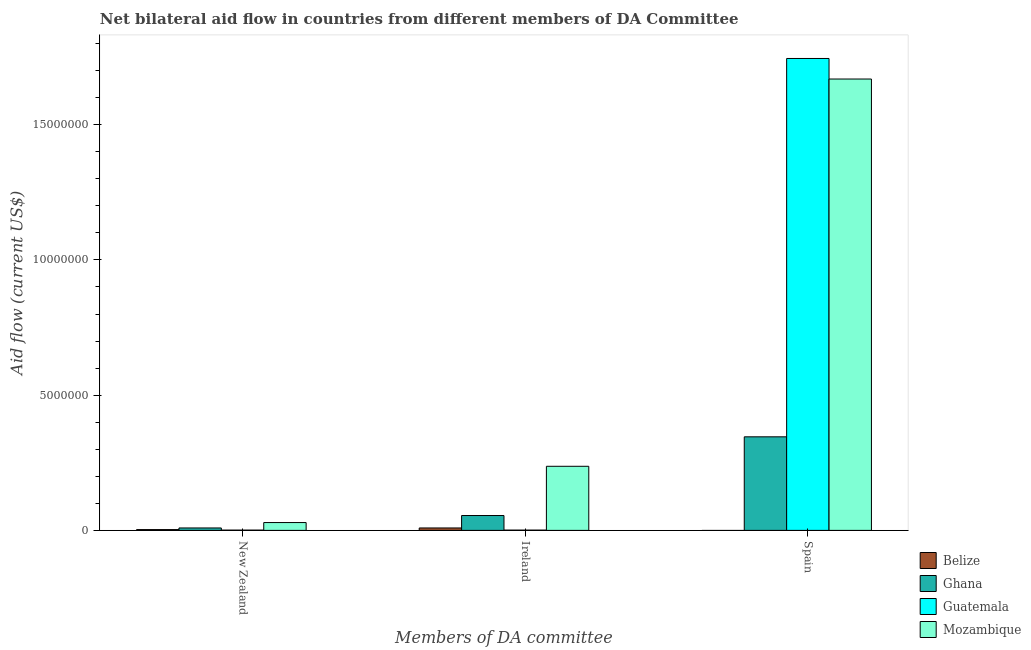How many groups of bars are there?
Make the answer very short. 3. Are the number of bars per tick equal to the number of legend labels?
Keep it short and to the point. No. How many bars are there on the 2nd tick from the left?
Provide a short and direct response. 4. What is the label of the 3rd group of bars from the left?
Your response must be concise. Spain. What is the amount of aid provided by new zealand in Ghana?
Your response must be concise. 9.00e+04. Across all countries, what is the maximum amount of aid provided by ireland?
Keep it short and to the point. 2.37e+06. Across all countries, what is the minimum amount of aid provided by spain?
Make the answer very short. 0. In which country was the amount of aid provided by ireland maximum?
Your response must be concise. Mozambique. What is the total amount of aid provided by new zealand in the graph?
Offer a very short reply. 4.20e+05. What is the difference between the amount of aid provided by new zealand in Guatemala and that in Mozambique?
Your response must be concise. -2.80e+05. What is the difference between the amount of aid provided by spain in Ghana and the amount of aid provided by ireland in Mozambique?
Give a very brief answer. 1.09e+06. What is the average amount of aid provided by spain per country?
Your answer should be very brief. 9.40e+06. What is the difference between the amount of aid provided by spain and amount of aid provided by new zealand in Mozambique?
Your answer should be compact. 1.64e+07. In how many countries, is the amount of aid provided by spain greater than 7000000 US$?
Ensure brevity in your answer.  2. What is the ratio of the amount of aid provided by new zealand in Guatemala to that in Mozambique?
Your response must be concise. 0.03. Is the difference between the amount of aid provided by ireland in Ghana and Mozambique greater than the difference between the amount of aid provided by spain in Ghana and Mozambique?
Keep it short and to the point. Yes. What is the difference between the highest and the second highest amount of aid provided by spain?
Offer a terse response. 7.60e+05. What is the difference between the highest and the lowest amount of aid provided by ireland?
Provide a succinct answer. 2.36e+06. Is it the case that in every country, the sum of the amount of aid provided by new zealand and amount of aid provided by ireland is greater than the amount of aid provided by spain?
Give a very brief answer. No. How many bars are there?
Your response must be concise. 11. Are all the bars in the graph horizontal?
Offer a terse response. No. How many countries are there in the graph?
Make the answer very short. 4. Does the graph contain grids?
Your answer should be compact. No. How many legend labels are there?
Make the answer very short. 4. How are the legend labels stacked?
Ensure brevity in your answer.  Vertical. What is the title of the graph?
Keep it short and to the point. Net bilateral aid flow in countries from different members of DA Committee. What is the label or title of the X-axis?
Make the answer very short. Members of DA committee. What is the label or title of the Y-axis?
Your response must be concise. Aid flow (current US$). What is the Aid flow (current US$) of Belize in New Zealand?
Offer a very short reply. 3.00e+04. What is the Aid flow (current US$) in Belize in Ireland?
Your response must be concise. 9.00e+04. What is the Aid flow (current US$) of Ghana in Ireland?
Your answer should be very brief. 5.50e+05. What is the Aid flow (current US$) in Mozambique in Ireland?
Your answer should be compact. 2.37e+06. What is the Aid flow (current US$) of Ghana in Spain?
Give a very brief answer. 3.46e+06. What is the Aid flow (current US$) in Guatemala in Spain?
Offer a very short reply. 1.74e+07. What is the Aid flow (current US$) of Mozambique in Spain?
Provide a succinct answer. 1.67e+07. Across all Members of DA committee, what is the maximum Aid flow (current US$) in Ghana?
Offer a terse response. 3.46e+06. Across all Members of DA committee, what is the maximum Aid flow (current US$) in Guatemala?
Give a very brief answer. 1.74e+07. Across all Members of DA committee, what is the maximum Aid flow (current US$) of Mozambique?
Your response must be concise. 1.67e+07. Across all Members of DA committee, what is the minimum Aid flow (current US$) in Belize?
Make the answer very short. 0. Across all Members of DA committee, what is the minimum Aid flow (current US$) of Ghana?
Offer a terse response. 9.00e+04. Across all Members of DA committee, what is the minimum Aid flow (current US$) in Mozambique?
Your response must be concise. 2.90e+05. What is the total Aid flow (current US$) of Ghana in the graph?
Give a very brief answer. 4.10e+06. What is the total Aid flow (current US$) in Guatemala in the graph?
Make the answer very short. 1.75e+07. What is the total Aid flow (current US$) in Mozambique in the graph?
Keep it short and to the point. 1.94e+07. What is the difference between the Aid flow (current US$) of Belize in New Zealand and that in Ireland?
Your answer should be very brief. -6.00e+04. What is the difference between the Aid flow (current US$) of Ghana in New Zealand and that in Ireland?
Make the answer very short. -4.60e+05. What is the difference between the Aid flow (current US$) of Guatemala in New Zealand and that in Ireland?
Provide a succinct answer. 0. What is the difference between the Aid flow (current US$) in Mozambique in New Zealand and that in Ireland?
Offer a terse response. -2.08e+06. What is the difference between the Aid flow (current US$) in Ghana in New Zealand and that in Spain?
Make the answer very short. -3.37e+06. What is the difference between the Aid flow (current US$) of Guatemala in New Zealand and that in Spain?
Your answer should be compact. -1.74e+07. What is the difference between the Aid flow (current US$) in Mozambique in New Zealand and that in Spain?
Keep it short and to the point. -1.64e+07. What is the difference between the Aid flow (current US$) of Ghana in Ireland and that in Spain?
Ensure brevity in your answer.  -2.91e+06. What is the difference between the Aid flow (current US$) in Guatemala in Ireland and that in Spain?
Give a very brief answer. -1.74e+07. What is the difference between the Aid flow (current US$) of Mozambique in Ireland and that in Spain?
Keep it short and to the point. -1.43e+07. What is the difference between the Aid flow (current US$) in Belize in New Zealand and the Aid flow (current US$) in Ghana in Ireland?
Your answer should be compact. -5.20e+05. What is the difference between the Aid flow (current US$) in Belize in New Zealand and the Aid flow (current US$) in Guatemala in Ireland?
Ensure brevity in your answer.  2.00e+04. What is the difference between the Aid flow (current US$) in Belize in New Zealand and the Aid flow (current US$) in Mozambique in Ireland?
Keep it short and to the point. -2.34e+06. What is the difference between the Aid flow (current US$) of Ghana in New Zealand and the Aid flow (current US$) of Mozambique in Ireland?
Offer a very short reply. -2.28e+06. What is the difference between the Aid flow (current US$) in Guatemala in New Zealand and the Aid flow (current US$) in Mozambique in Ireland?
Give a very brief answer. -2.36e+06. What is the difference between the Aid flow (current US$) of Belize in New Zealand and the Aid flow (current US$) of Ghana in Spain?
Keep it short and to the point. -3.43e+06. What is the difference between the Aid flow (current US$) of Belize in New Zealand and the Aid flow (current US$) of Guatemala in Spain?
Your answer should be compact. -1.74e+07. What is the difference between the Aid flow (current US$) in Belize in New Zealand and the Aid flow (current US$) in Mozambique in Spain?
Make the answer very short. -1.67e+07. What is the difference between the Aid flow (current US$) of Ghana in New Zealand and the Aid flow (current US$) of Guatemala in Spain?
Give a very brief answer. -1.74e+07. What is the difference between the Aid flow (current US$) of Ghana in New Zealand and the Aid flow (current US$) of Mozambique in Spain?
Provide a short and direct response. -1.66e+07. What is the difference between the Aid flow (current US$) in Guatemala in New Zealand and the Aid flow (current US$) in Mozambique in Spain?
Keep it short and to the point. -1.67e+07. What is the difference between the Aid flow (current US$) in Belize in Ireland and the Aid flow (current US$) in Ghana in Spain?
Offer a terse response. -3.37e+06. What is the difference between the Aid flow (current US$) in Belize in Ireland and the Aid flow (current US$) in Guatemala in Spain?
Make the answer very short. -1.74e+07. What is the difference between the Aid flow (current US$) in Belize in Ireland and the Aid flow (current US$) in Mozambique in Spain?
Your response must be concise. -1.66e+07. What is the difference between the Aid flow (current US$) in Ghana in Ireland and the Aid flow (current US$) in Guatemala in Spain?
Offer a very short reply. -1.69e+07. What is the difference between the Aid flow (current US$) in Ghana in Ireland and the Aid flow (current US$) in Mozambique in Spain?
Offer a terse response. -1.61e+07. What is the difference between the Aid flow (current US$) in Guatemala in Ireland and the Aid flow (current US$) in Mozambique in Spain?
Your answer should be compact. -1.67e+07. What is the average Aid flow (current US$) of Belize per Members of DA committee?
Offer a terse response. 4.00e+04. What is the average Aid flow (current US$) of Ghana per Members of DA committee?
Give a very brief answer. 1.37e+06. What is the average Aid flow (current US$) in Guatemala per Members of DA committee?
Provide a short and direct response. 5.82e+06. What is the average Aid flow (current US$) of Mozambique per Members of DA committee?
Your answer should be very brief. 6.45e+06. What is the difference between the Aid flow (current US$) of Belize and Aid flow (current US$) of Ghana in New Zealand?
Make the answer very short. -6.00e+04. What is the difference between the Aid flow (current US$) of Ghana and Aid flow (current US$) of Guatemala in New Zealand?
Your response must be concise. 8.00e+04. What is the difference between the Aid flow (current US$) in Guatemala and Aid flow (current US$) in Mozambique in New Zealand?
Make the answer very short. -2.80e+05. What is the difference between the Aid flow (current US$) of Belize and Aid flow (current US$) of Ghana in Ireland?
Give a very brief answer. -4.60e+05. What is the difference between the Aid flow (current US$) of Belize and Aid flow (current US$) of Guatemala in Ireland?
Keep it short and to the point. 8.00e+04. What is the difference between the Aid flow (current US$) of Belize and Aid flow (current US$) of Mozambique in Ireland?
Provide a short and direct response. -2.28e+06. What is the difference between the Aid flow (current US$) in Ghana and Aid flow (current US$) in Guatemala in Ireland?
Your answer should be very brief. 5.40e+05. What is the difference between the Aid flow (current US$) of Ghana and Aid flow (current US$) of Mozambique in Ireland?
Your answer should be very brief. -1.82e+06. What is the difference between the Aid flow (current US$) in Guatemala and Aid flow (current US$) in Mozambique in Ireland?
Your answer should be very brief. -2.36e+06. What is the difference between the Aid flow (current US$) of Ghana and Aid flow (current US$) of Guatemala in Spain?
Your answer should be compact. -1.40e+07. What is the difference between the Aid flow (current US$) of Ghana and Aid flow (current US$) of Mozambique in Spain?
Keep it short and to the point. -1.32e+07. What is the difference between the Aid flow (current US$) in Guatemala and Aid flow (current US$) in Mozambique in Spain?
Give a very brief answer. 7.60e+05. What is the ratio of the Aid flow (current US$) of Belize in New Zealand to that in Ireland?
Provide a short and direct response. 0.33. What is the ratio of the Aid flow (current US$) in Ghana in New Zealand to that in Ireland?
Keep it short and to the point. 0.16. What is the ratio of the Aid flow (current US$) in Guatemala in New Zealand to that in Ireland?
Ensure brevity in your answer.  1. What is the ratio of the Aid flow (current US$) of Mozambique in New Zealand to that in Ireland?
Give a very brief answer. 0.12. What is the ratio of the Aid flow (current US$) in Ghana in New Zealand to that in Spain?
Your answer should be very brief. 0.03. What is the ratio of the Aid flow (current US$) in Guatemala in New Zealand to that in Spain?
Provide a short and direct response. 0. What is the ratio of the Aid flow (current US$) of Mozambique in New Zealand to that in Spain?
Offer a very short reply. 0.02. What is the ratio of the Aid flow (current US$) in Ghana in Ireland to that in Spain?
Make the answer very short. 0.16. What is the ratio of the Aid flow (current US$) of Guatemala in Ireland to that in Spain?
Offer a very short reply. 0. What is the ratio of the Aid flow (current US$) of Mozambique in Ireland to that in Spain?
Keep it short and to the point. 0.14. What is the difference between the highest and the second highest Aid flow (current US$) of Ghana?
Provide a succinct answer. 2.91e+06. What is the difference between the highest and the second highest Aid flow (current US$) in Guatemala?
Offer a terse response. 1.74e+07. What is the difference between the highest and the second highest Aid flow (current US$) of Mozambique?
Ensure brevity in your answer.  1.43e+07. What is the difference between the highest and the lowest Aid flow (current US$) in Belize?
Provide a succinct answer. 9.00e+04. What is the difference between the highest and the lowest Aid flow (current US$) of Ghana?
Provide a short and direct response. 3.37e+06. What is the difference between the highest and the lowest Aid flow (current US$) in Guatemala?
Provide a succinct answer. 1.74e+07. What is the difference between the highest and the lowest Aid flow (current US$) in Mozambique?
Offer a very short reply. 1.64e+07. 